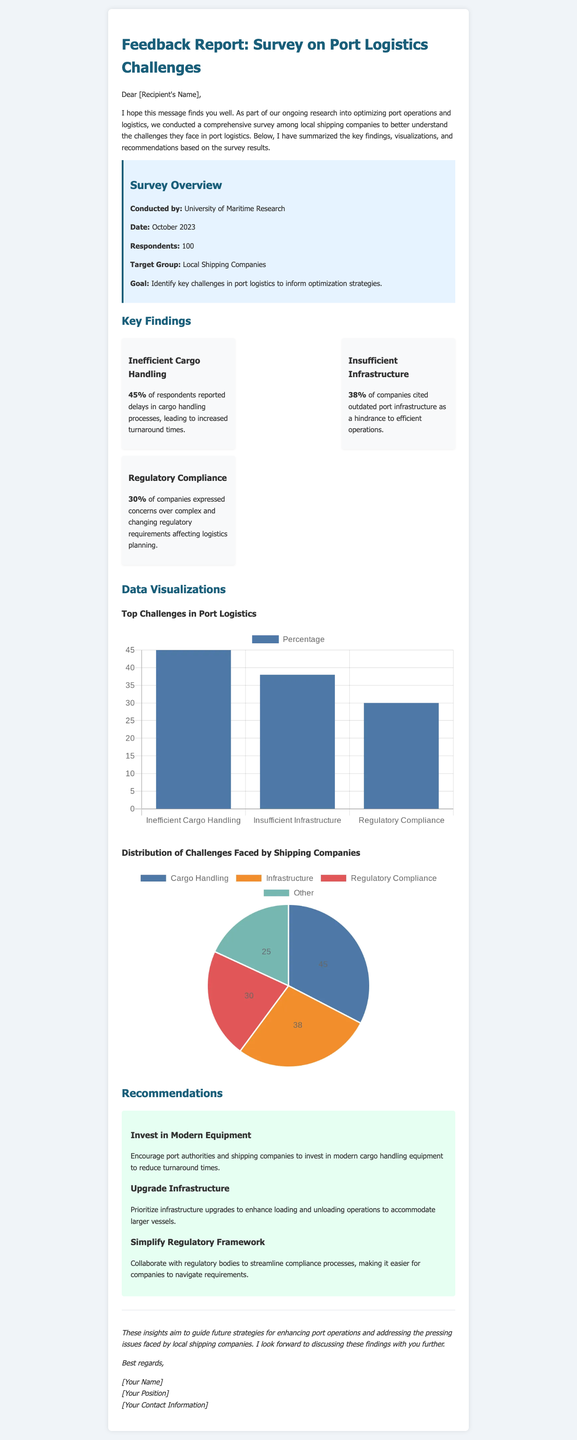what is the title of the document? The title is provided in the header of the document, summarizing the survey's focus on port logistics challenges.
Answer: Feedback Report: Survey on Port Logistics Challenges how many respondents participated in the survey? The number of respondents is highlighted in the survey overview section.
Answer: 100 what percentage of companies reported delays in cargo handling processes? The survey findings state the percentage for delays in cargo handling within the key findings section.
Answer: 45% which issue was cited by 38% of companies? This information is found in the key findings, specifying the issues reported by the companies.
Answer: Insufficient Infrastructure what recommendation suggests investing in modern equipment? The recommendation specifically related to this investment can be found in the recommendations section.
Answer: Invest in Modern Equipment which organization conducted the survey? The organization is mentioned in the survey overview section, indicating who carried out the survey.
Answer: University of Maritime Research what is the goal of the survey? The goal is summarized in the survey overview section, outlining the purpose of the survey.
Answer: Identify key challenges in port logistics to inform optimization strategies which regulatory concern was expressed by 30% of the respondents? This concern is detailed in the key findings, summarizing the challenges faced by shipping companies.
Answer: Complex and changing regulatory requirements what type of chart visualizes the distribution of challenges faced by shipping companies? The type of chart is specified in the data visualizations section of the document.
Answer: Pie chart 